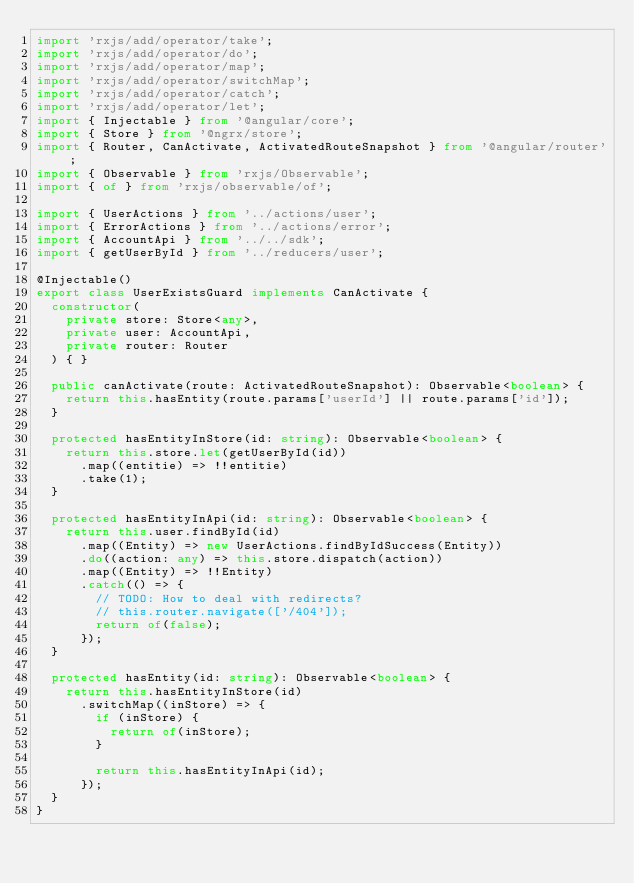Convert code to text. <code><loc_0><loc_0><loc_500><loc_500><_TypeScript_>import 'rxjs/add/operator/take';
import 'rxjs/add/operator/do';
import 'rxjs/add/operator/map';
import 'rxjs/add/operator/switchMap';
import 'rxjs/add/operator/catch';
import 'rxjs/add/operator/let';
import { Injectable } from '@angular/core';
import { Store } from '@ngrx/store';
import { Router, CanActivate, ActivatedRouteSnapshot } from '@angular/router';
import { Observable } from 'rxjs/Observable';
import { of } from 'rxjs/observable/of';

import { UserActions } from '../actions/user';
import { ErrorActions } from '../actions/error';
import { AccountApi } from '../../sdk';
import { getUserById } from '../reducers/user';

@Injectable()
export class UserExistsGuard implements CanActivate {
  constructor(
    private store: Store<any>,
    private user: AccountApi,
    private router: Router
  ) { }

  public canActivate(route: ActivatedRouteSnapshot): Observable<boolean> {
    return this.hasEntity(route.params['userId'] || route.params['id']);
  }

  protected hasEntityInStore(id: string): Observable<boolean> {
    return this.store.let(getUserById(id))
      .map((entitie) => !!entitie)
      .take(1);
  }

  protected hasEntityInApi(id: string): Observable<boolean> {
    return this.user.findById(id)
      .map((Entity) => new UserActions.findByIdSuccess(Entity))
      .do((action: any) => this.store.dispatch(action))
      .map((Entity) => !!Entity)
      .catch(() => {
        // TODO: How to deal with redirects?
        // this.router.navigate(['/404']);
        return of(false);
      });
  }

  protected hasEntity(id: string): Observable<boolean> {
    return this.hasEntityInStore(id)
      .switchMap((inStore) => {
        if (inStore) {
          return of(inStore);
        }

        return this.hasEntityInApi(id);
      });
  }
}
</code> 